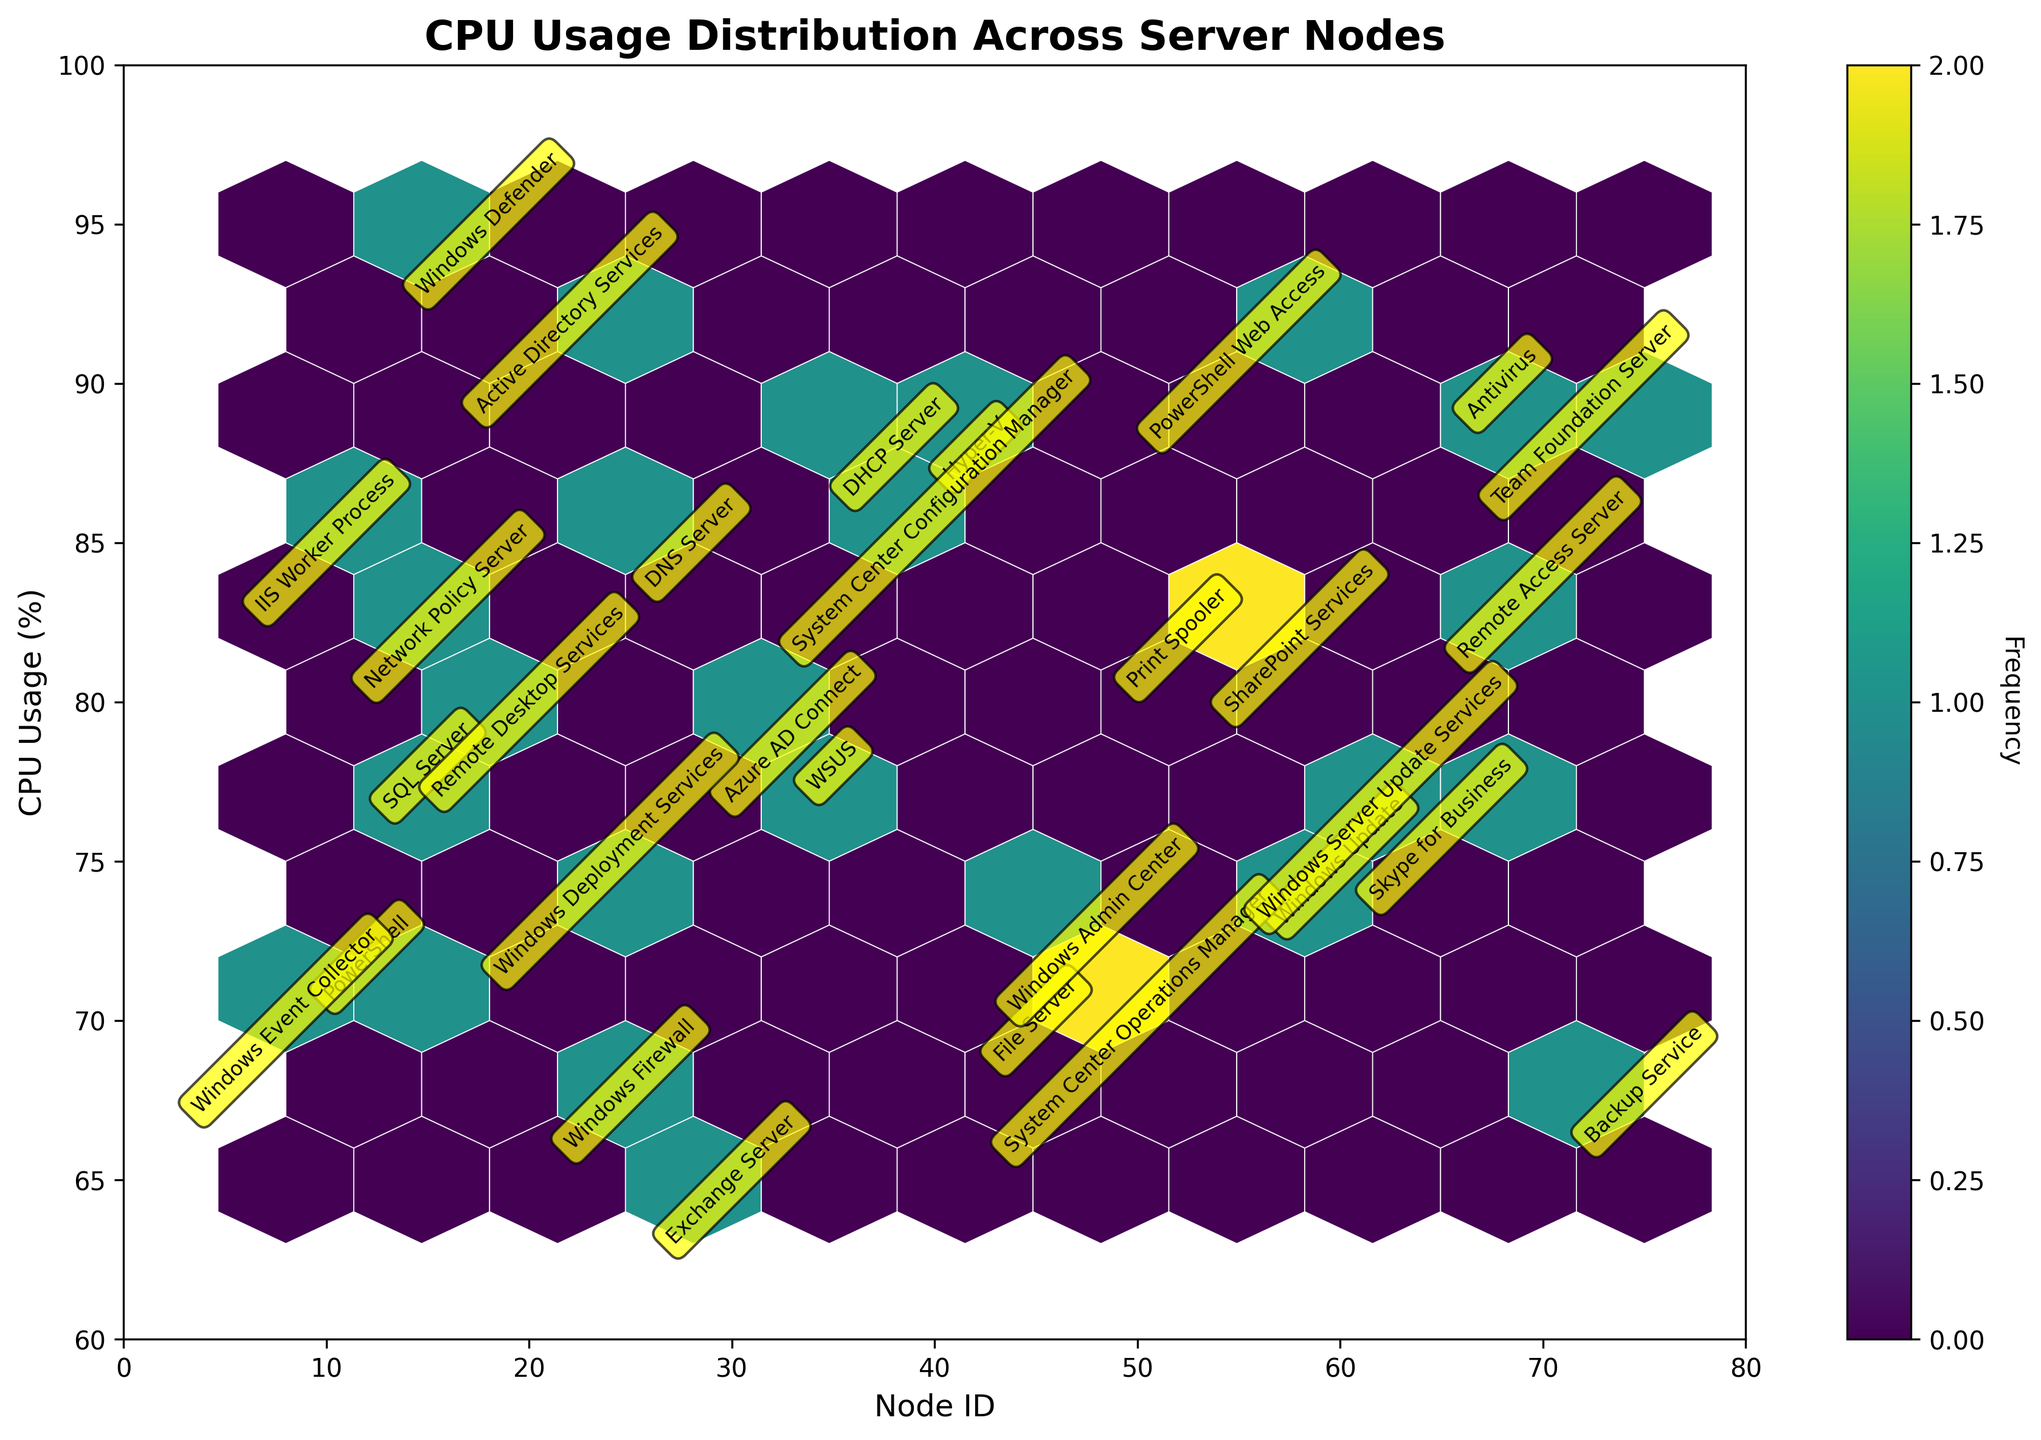What is the title of the figure? The title can be found at the top of the figure, typically in a larger and bold font. It summarizes what the plot is about.
Answer: CPU Usage Distribution Across Server Nodes What does the x-axis represent? The x-axis label can be found on the horizontal line of the plot. It indicates the type of data plotted along the x-axis.
Answer: Node ID Which process type has a CPU usage of 95%? The annotations on the plot provide process type names at their corresponding data points.
Answer: Windows Defender How many processes have a CPU usage greater than 85%? Look at the annotations and count the number of processes with y-values greater than 85%.
Answer: 7 Which process type is located at the highest CPU usage in the plot? The highest CPU usage will be found at the top of the plot, identified by the annotation.
Answer: Windows Defender What is the range of CPU usage values represented on the y-axis? The range of values can be determined by examining the minimum and maximum ticks on the y-axis.
Answer: 60% to 100% Which node ID has the least CPU usage associated with PowerShell? Identify the annotation for "PowerShell" and note the corresponding x and y values.
Answer: 12 Compare the CPU usage of Remote Desktop Services and Azure AD Connect. Which one is higher? Find the annotations for Remote Desktop Services and Azure AD Connect and compare their y-values.
Answer: Remote Desktop Services What is the color map used for the hexbin plot? The color map can be referenced in the plot's code description or visually identified from the plot's color gradient.
Answer: Viridis Which node ID has the highest frequency in the hexbin plot? Identify the hexagon with the most intense color (highest frequency) and note its x-value. The specific node ID will typically have the highest point count associated.
Answer: Not directly answerable since frequency values are not provided (note this for the user) 